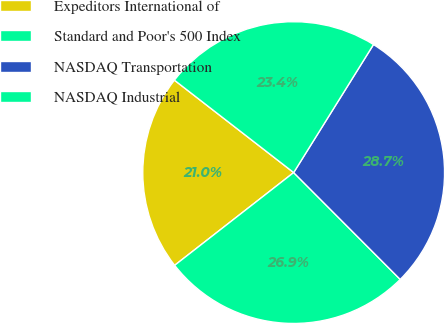<chart> <loc_0><loc_0><loc_500><loc_500><pie_chart><fcel>Expeditors International of<fcel>Standard and Poor's 500 Index<fcel>NASDAQ Transportation<fcel>NASDAQ Industrial<nl><fcel>21.03%<fcel>26.94%<fcel>28.65%<fcel>23.38%<nl></chart> 